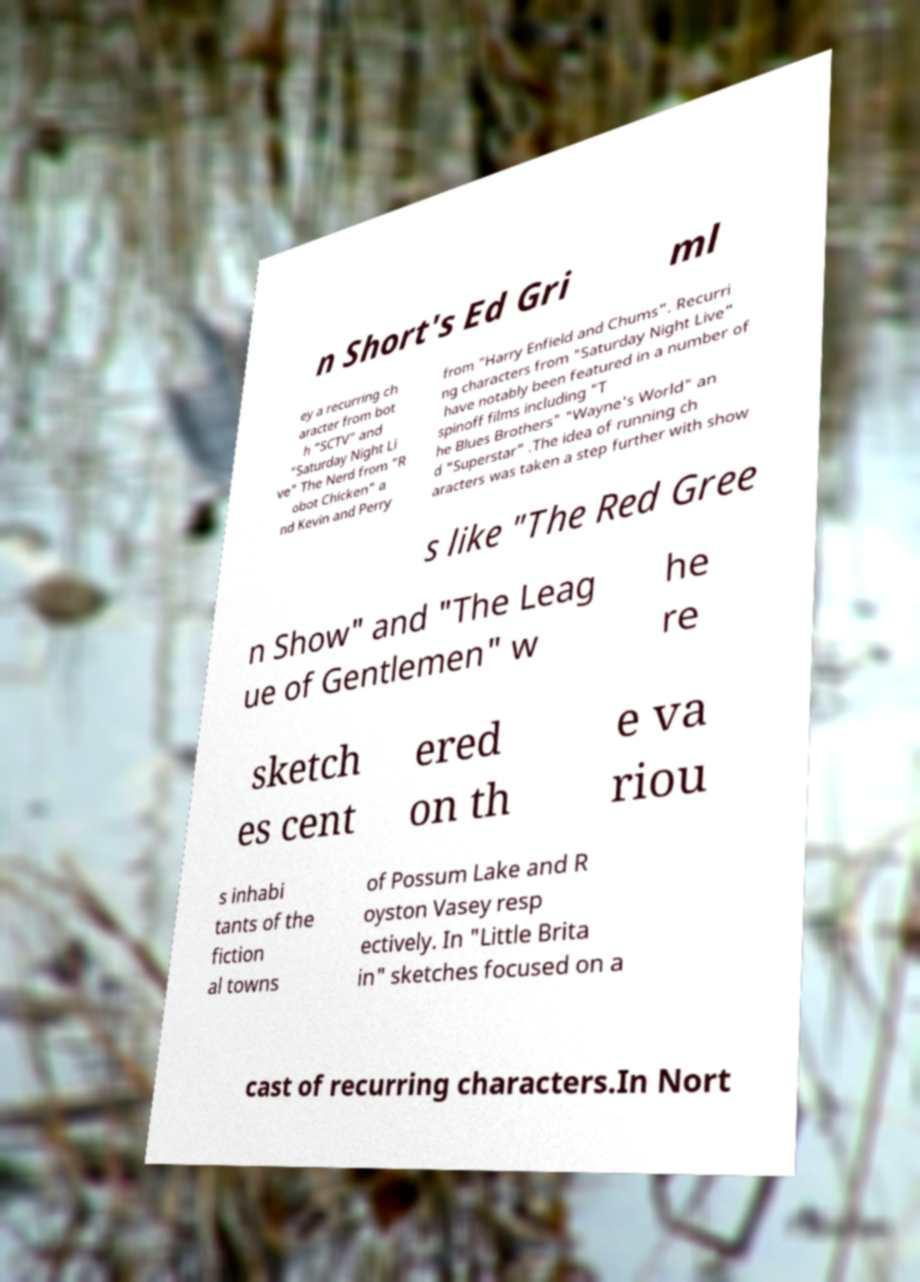What messages or text are displayed in this image? I need them in a readable, typed format. n Short's Ed Gri ml ey a recurring ch aracter from bot h "SCTV" and "Saturday Night Li ve" The Nerd from "R obot Chicken" a nd Kevin and Perry from "Harry Enfield and Chums". Recurri ng characters from "Saturday Night Live" have notably been featured in a number of spinoff films including "T he Blues Brothers" "Wayne's World" an d "Superstar" .The idea of running ch aracters was taken a step further with show s like "The Red Gree n Show" and "The Leag ue of Gentlemen" w he re sketch es cent ered on th e va riou s inhabi tants of the fiction al towns of Possum Lake and R oyston Vasey resp ectively. In "Little Brita in" sketches focused on a cast of recurring characters.In Nort 